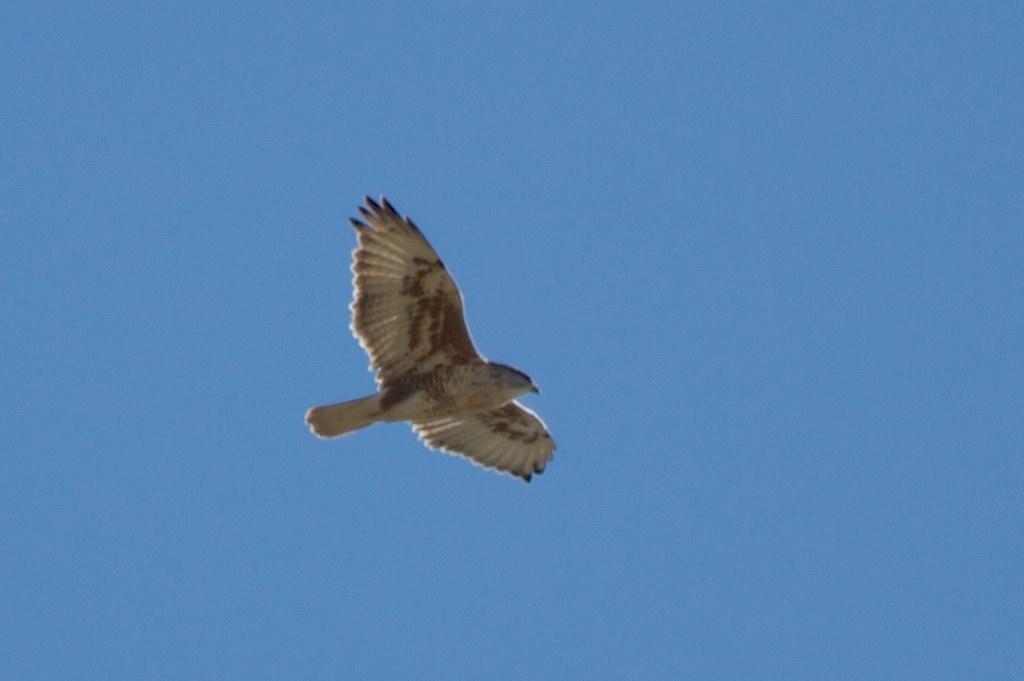Can you describe this image briefly? This image consists of a bird. It is in yellow color. There is sky in this image. 